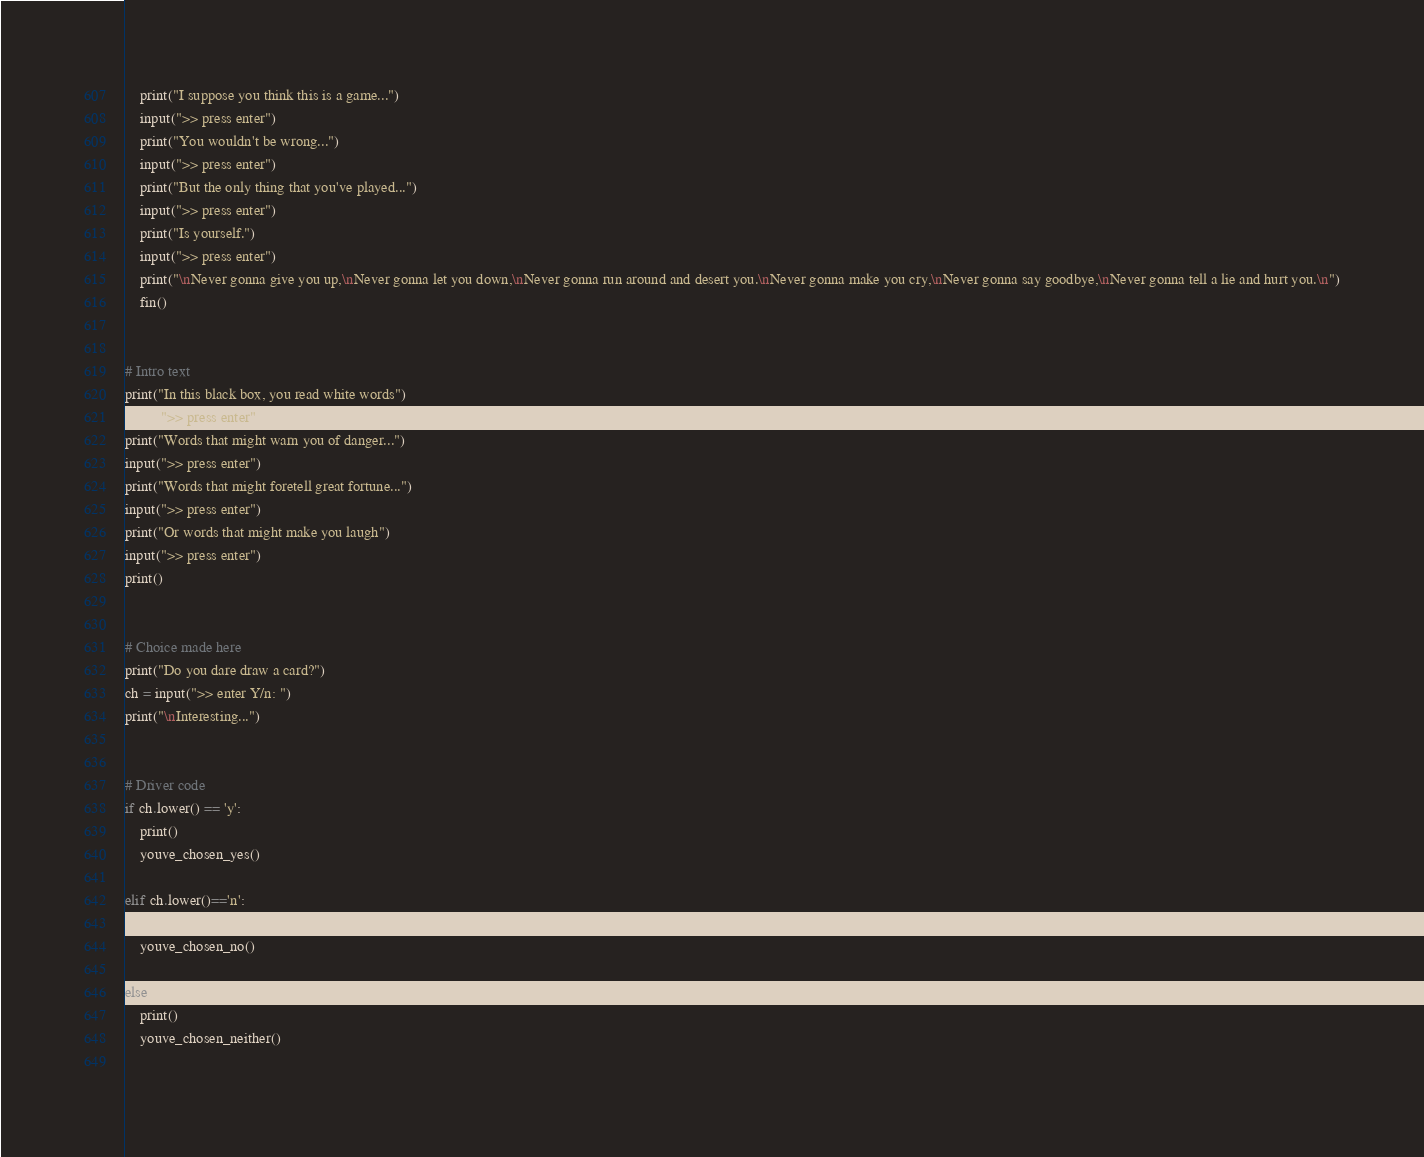Convert code to text. <code><loc_0><loc_0><loc_500><loc_500><_Python_>    print("I suppose you think this is a game...")
    input(">> press enter")
    print("You wouldn't be wrong...")
    input(">> press enter")
    print("But the only thing that you've played...")
    input(">> press enter")
    print("Is yourself.")
    input(">> press enter")
    print("\nNever gonna give you up,\nNever gonna let you down,\nNever gonna run around and desert you.\nNever gonna make you cry,\nNever gonna say goodbye,\nNever gonna tell a lie and hurt you.\n")
    fin()


# Intro text
print("In this black box, you read white words")
input(">> press enter")
print("Words that might warn you of danger...")
input(">> press enter")
print("Words that might foretell great fortune...")
input(">> press enter")
print("Or words that might make you laugh")
input(">> press enter")
print()


# Choice made here
print("Do you dare draw a card?")
ch = input(">> enter Y/n: ")
print("\nInteresting...")


# Driver code
if ch.lower() == 'y':
    print()
    youve_chosen_yes()

elif ch.lower()=='n':
    print()
    youve_chosen_no()

else:
    print()
    youve_chosen_neither()
    
</code> 